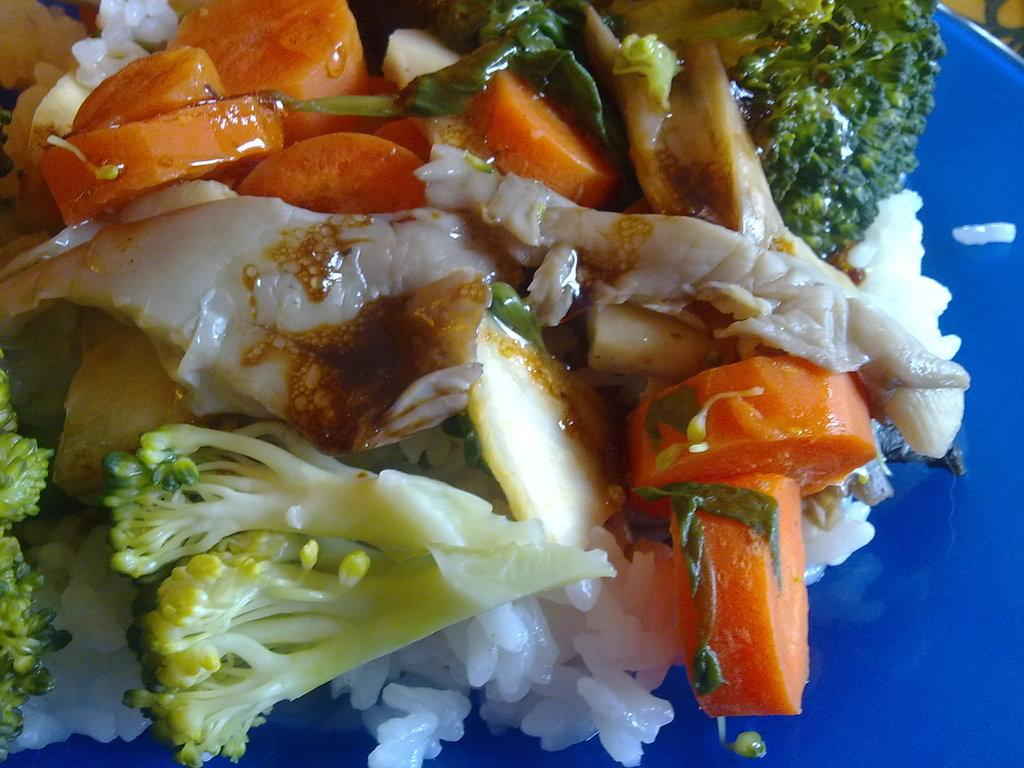What object is present in the image that typically holds food? There is a plate in the image. What is on the plate? The plate contains food. What type of button can be seen on the plate in the image? There is no button present on the plate in the image. What material is the metal duck made of in the image? There is no metal duck present in the image. 